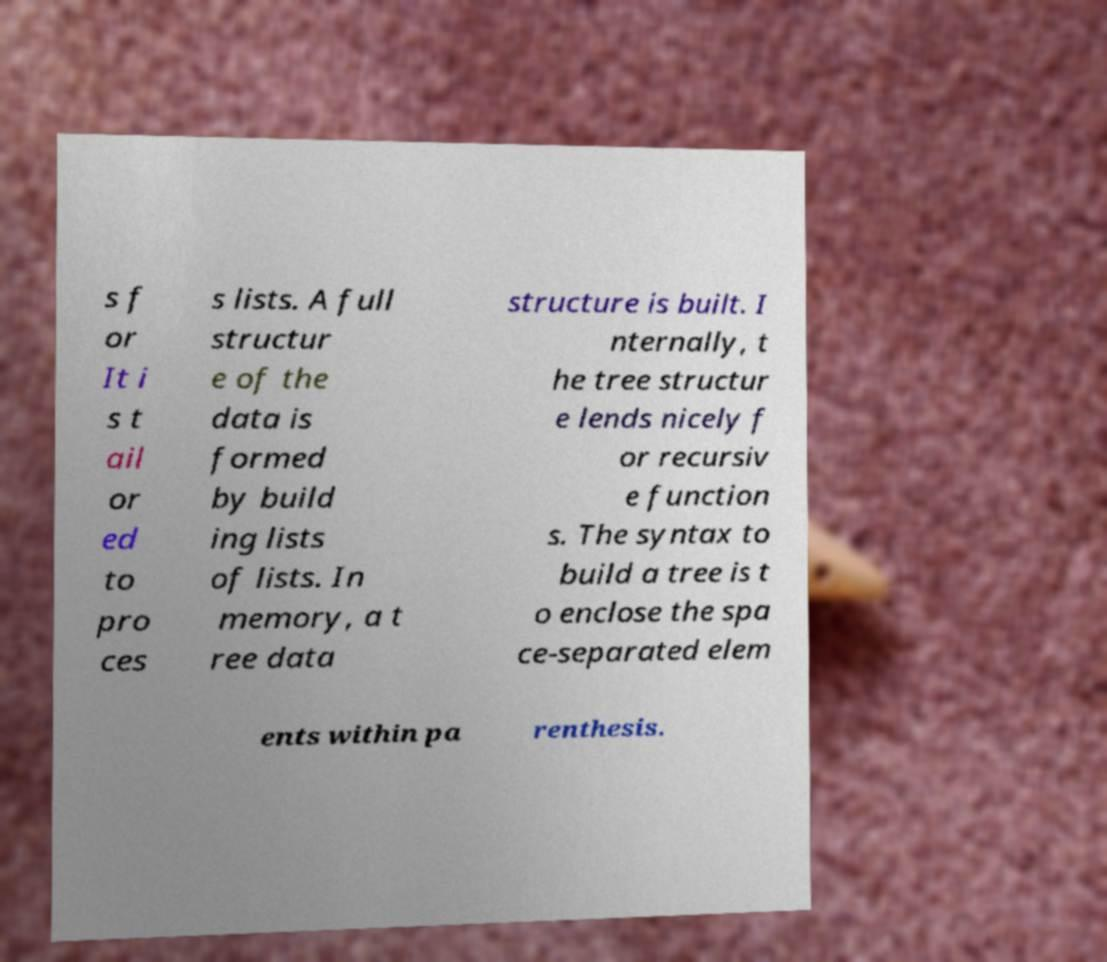Can you read and provide the text displayed in the image?This photo seems to have some interesting text. Can you extract and type it out for me? s f or It i s t ail or ed to pro ces s lists. A full structur e of the data is formed by build ing lists of lists. In memory, a t ree data structure is built. I nternally, t he tree structur e lends nicely f or recursiv e function s. The syntax to build a tree is t o enclose the spa ce-separated elem ents within pa renthesis. 